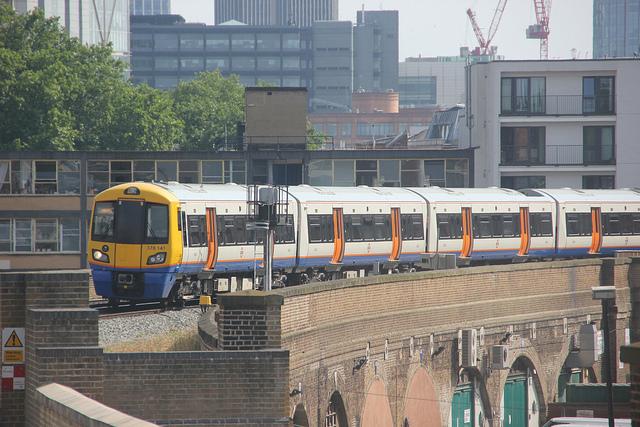Where is the crane?
Keep it brief. Background. Which direction is the train traveling?
Concise answer only. North. How many light on the front of the train are lit?
Keep it brief. 1. Is this a rural scene?
Keep it brief. No. Is this a form of public transportation?
Write a very short answer. Yes. 